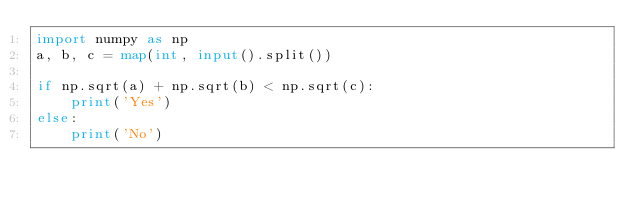Convert code to text. <code><loc_0><loc_0><loc_500><loc_500><_Python_>import numpy as np
a, b, c = map(int, input().split())

if np.sqrt(a) + np.sqrt(b) < np.sqrt(c):
    print('Yes')
else:
    print('No')</code> 